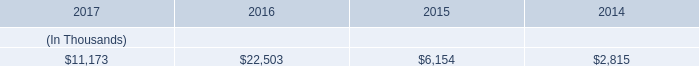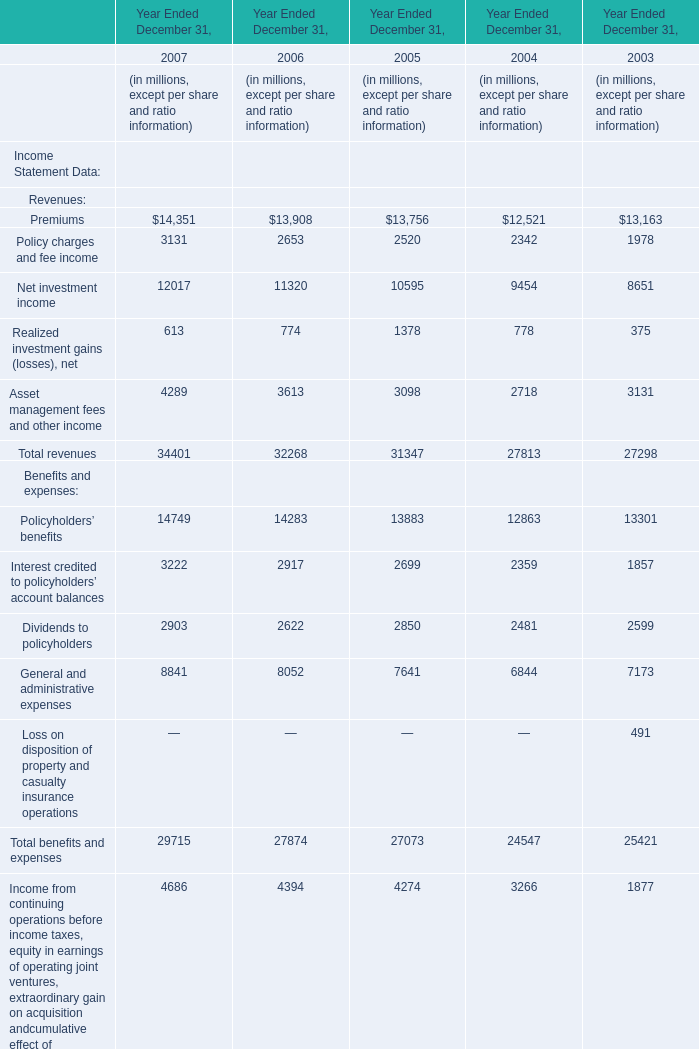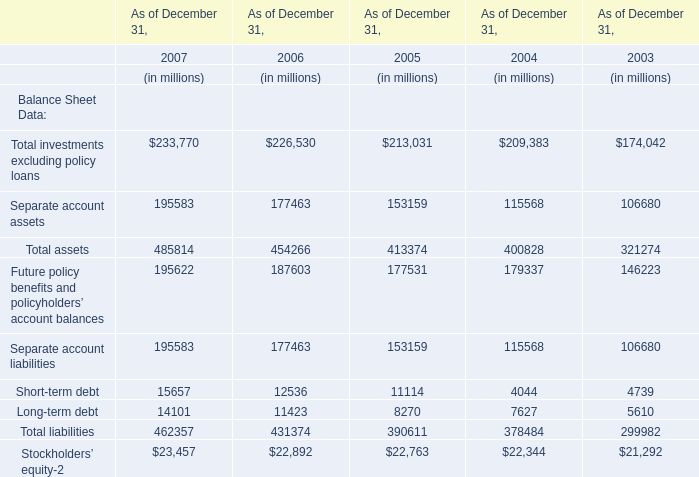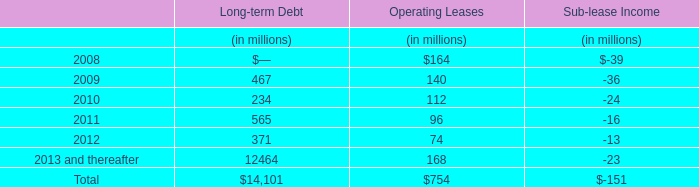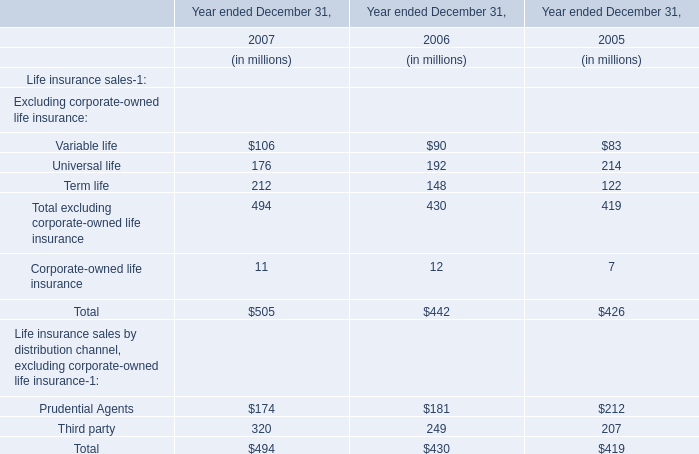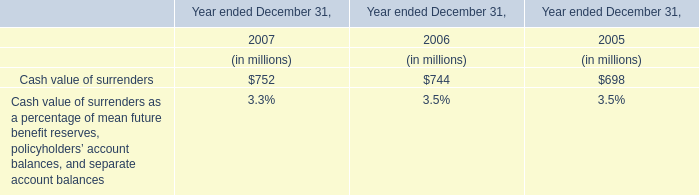What is the average of Net investment income between 2006 and 2007? (in million) 
Computations: ((12017 - 11320) / 2)
Answer: 348.5. 